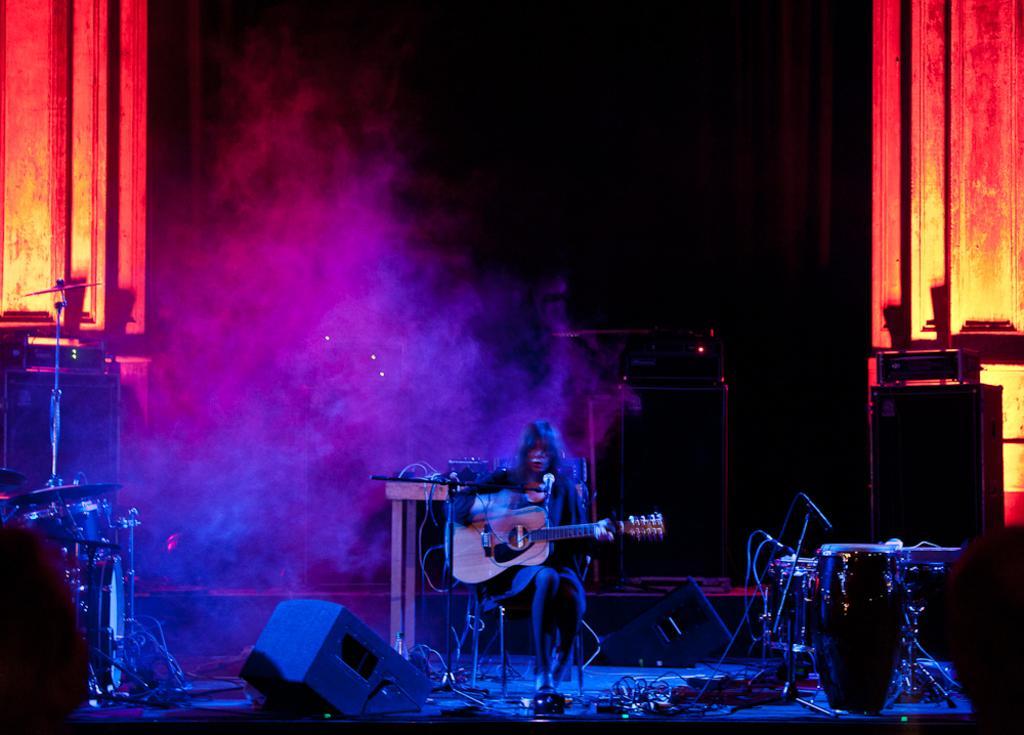Could you give a brief overview of what you see in this image? This picture is of inside. In the center there is a person sitting on the chair and playing guitar. On the right there are some musical instruments. In the background we can see the wall, a machine placed on the top of the table and lights. 